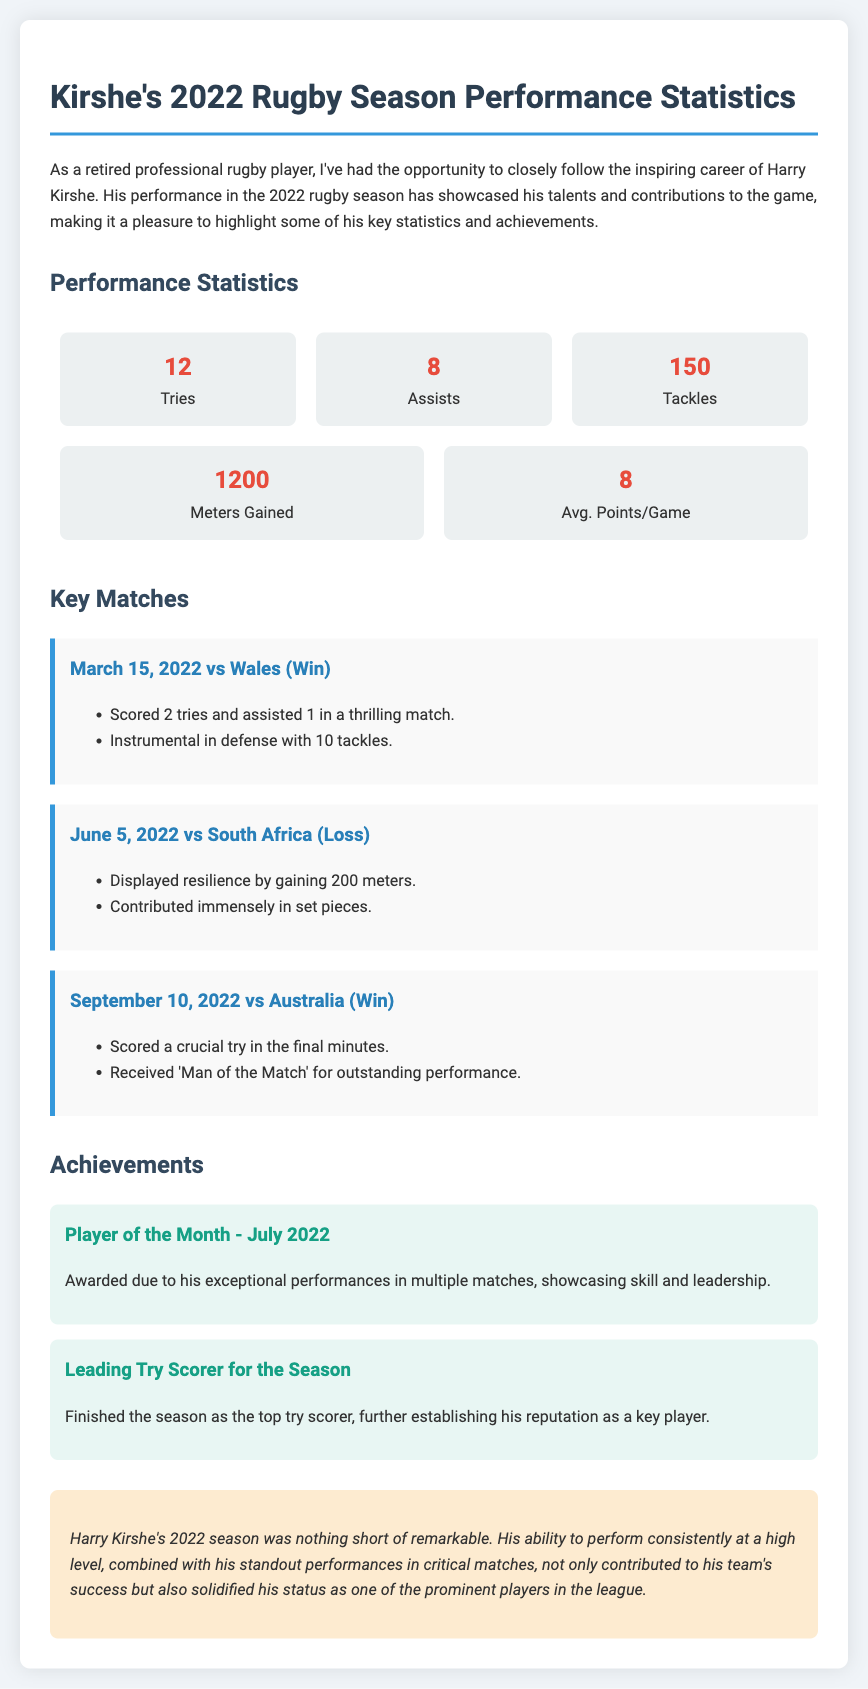what was Kirshe's total number of tries in the 2022 season? The total number of tries is mentioned in the performance statistics section, where it states he scored 12 tries.
Answer: 12 how many assists did Kirshe have? The performance statistics section indicates that he made 8 assists during the season.
Answer: 8 what were Kirshe's average points per game? The average points per game are highlighted as part of his performance statistics, which states 8 average points.
Answer: 8 which match did Kirshe receive 'Man of the Match'? The key matches section notes that he received the 'Man of the Match' title in the match against Australia on September 10, 2022.
Answer: Australia when was Kirshe awarded Player of the Month? The achievements section specifies that he was awarded Player of the Month in July 2022 due to his exceptional performances.
Answer: July 2022 how many tackles did Kirshe complete in the match against Wales? In the key matches section for the Wales match, it mentions that Kirshe made 10 tackles.
Answer: 10 how many meters did Kirshe gain in the match against South Africa? The key matches section outlines that Kirshe gained 200 meters in the South Africa match.
Answer: 200 what achievement recognizes Kirshe as the top try scorer? The achievements section states that he finished the season as the leading try scorer, recognizing his exemplary performance.
Answer: Leading Try Scorer what is a summary description of Kirshe's 2022 season? The summary section provides an overall evaluation of Kirshe's season, stating it was remarkable due to consistent high-level performances.
Answer: Remarkable 